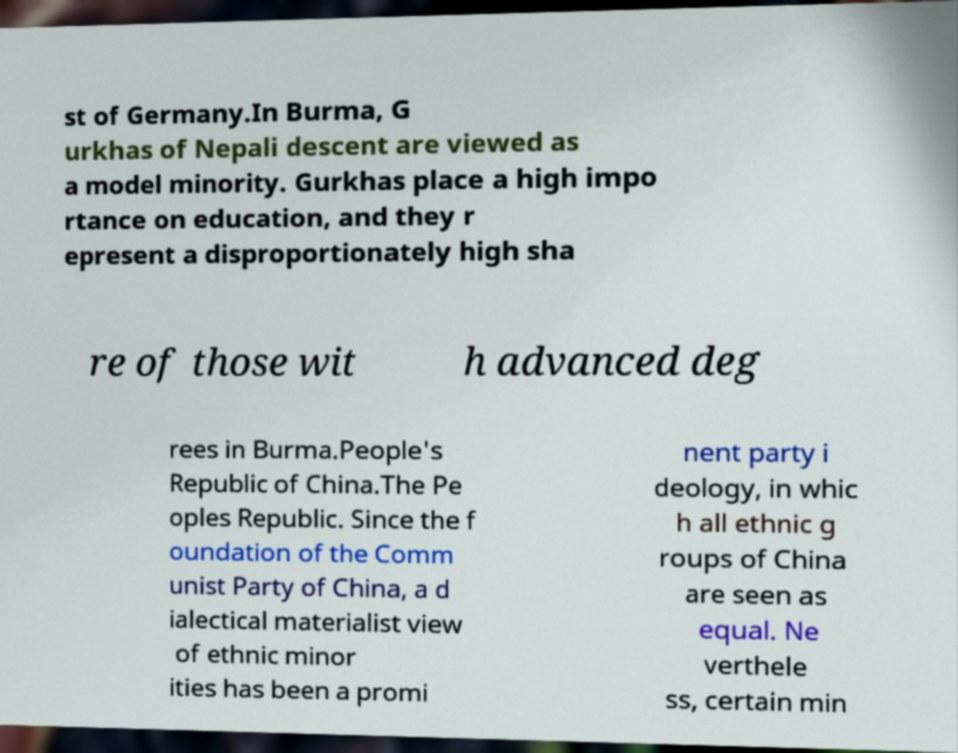Could you assist in decoding the text presented in this image and type it out clearly? st of Germany.In Burma, G urkhas of Nepali descent are viewed as a model minority. Gurkhas place a high impo rtance on education, and they r epresent a disproportionately high sha re of those wit h advanced deg rees in Burma.People's Republic of China.The Pe oples Republic. Since the f oundation of the Comm unist Party of China, a d ialectical materialist view of ethnic minor ities has been a promi nent party i deology, in whic h all ethnic g roups of China are seen as equal. Ne verthele ss, certain min 